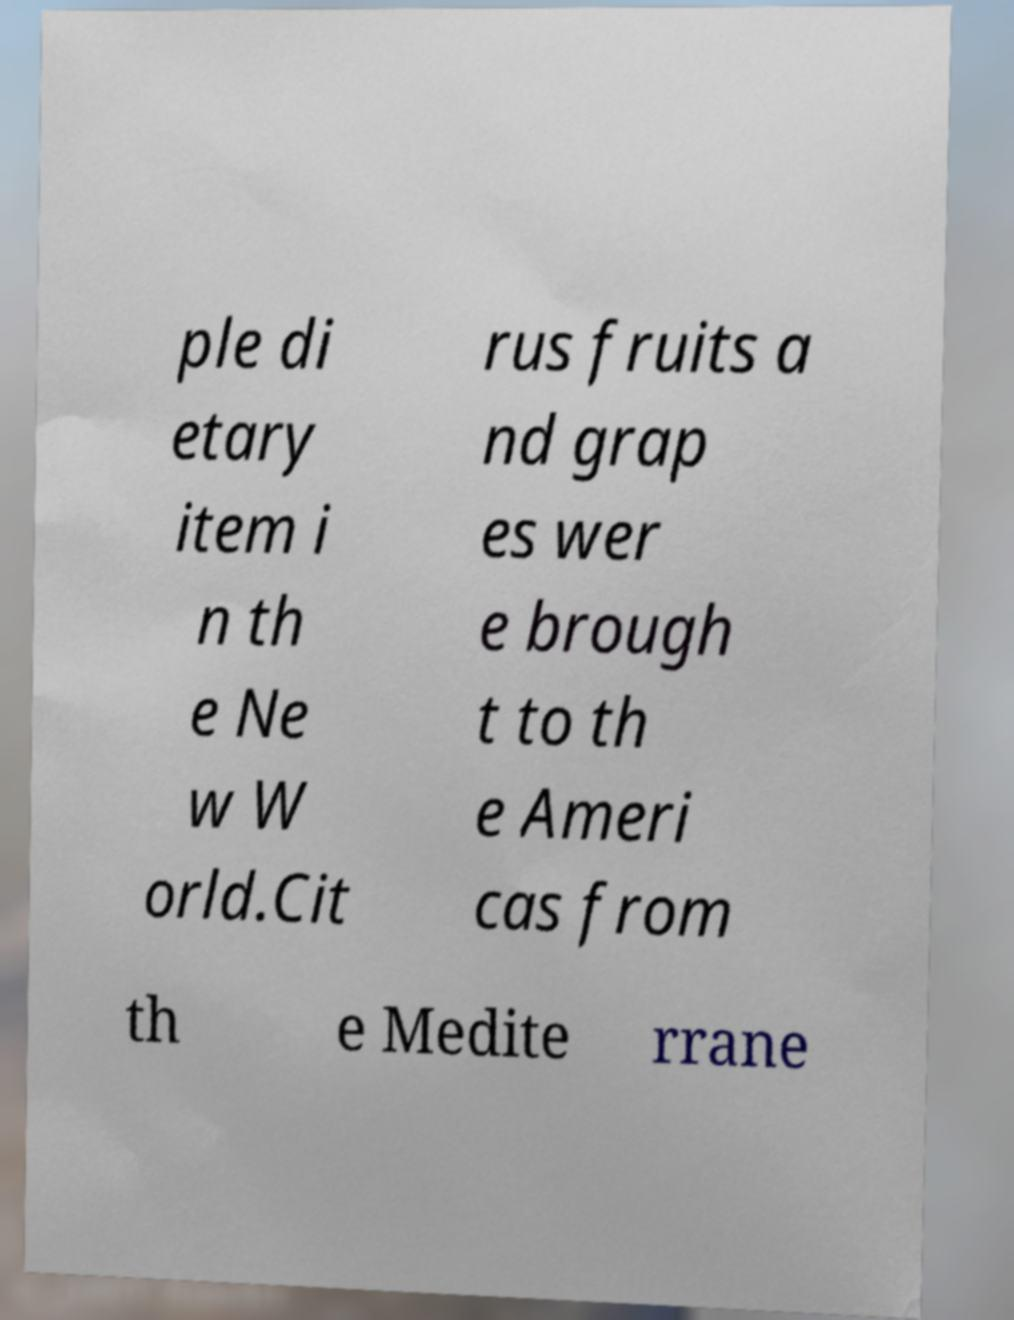Can you accurately transcribe the text from the provided image for me? ple di etary item i n th e Ne w W orld.Cit rus fruits a nd grap es wer e brough t to th e Ameri cas from th e Medite rrane 